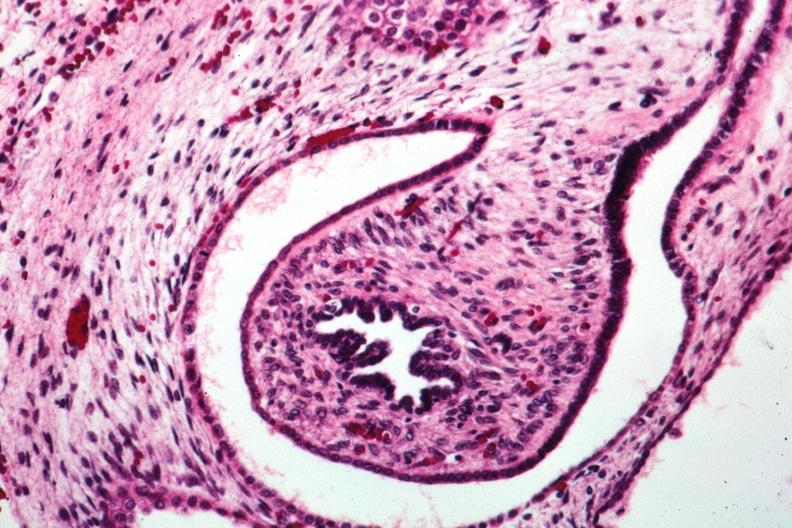what is present?
Answer the question using a single word or phrase. Kidney 